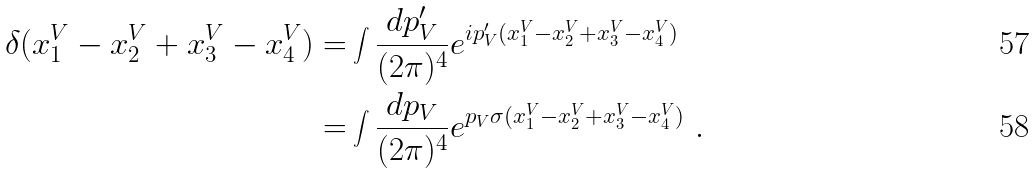Convert formula to latex. <formula><loc_0><loc_0><loc_500><loc_500>\delta ( x _ { 1 } ^ { V } - x _ { 2 } ^ { V } + x _ { 3 } ^ { V } - x _ { 4 } ^ { V } ) = & \int \frac { d p ^ { \prime } _ { V } } { ( 2 \pi ) ^ { 4 } } e ^ { i p ^ { \prime } _ { V } ( x _ { 1 } ^ { V } - x _ { 2 } ^ { V } + x _ { 3 } ^ { V } - x _ { 4 } ^ { V } ) } \\ = & \int \frac { d p _ { V } } { ( 2 \pi ) ^ { 4 } } e ^ { p _ { V } \sigma ( x _ { 1 } ^ { V } - x _ { 2 } ^ { V } + x _ { 3 } ^ { V } - x _ { 4 } ^ { V } ) } \ .</formula> 